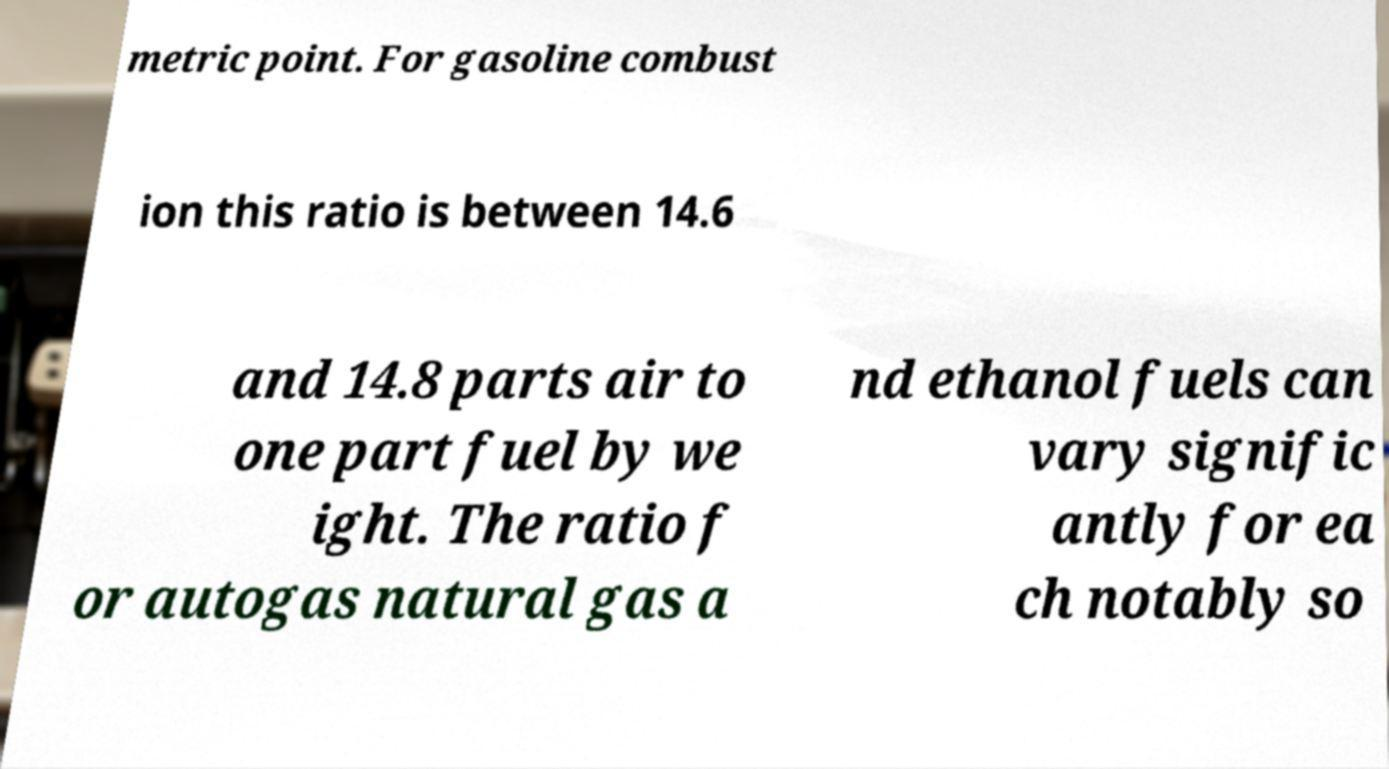What messages or text are displayed in this image? I need them in a readable, typed format. metric point. For gasoline combust ion this ratio is between 14.6 and 14.8 parts air to one part fuel by we ight. The ratio f or autogas natural gas a nd ethanol fuels can vary signific antly for ea ch notably so 